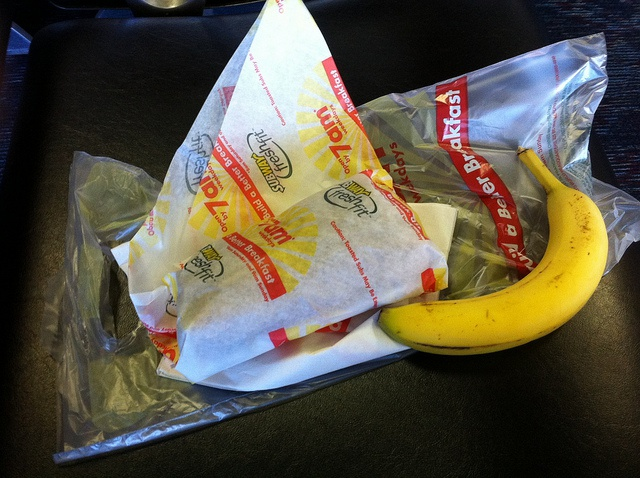Describe the objects in this image and their specific colors. I can see dining table in black, gray, darkgreen, and darkgray tones, sandwich in black, darkgray, tan, and olive tones, and banana in black, gold, and olive tones in this image. 